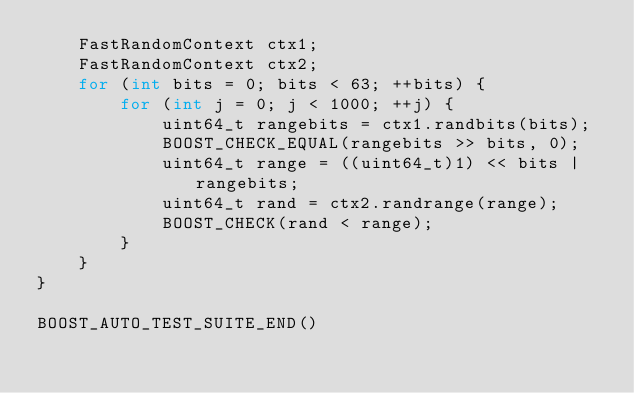<code> <loc_0><loc_0><loc_500><loc_500><_C++_>    FastRandomContext ctx1;
    FastRandomContext ctx2;
    for (int bits = 0; bits < 63; ++bits) {
        for (int j = 0; j < 1000; ++j) {
            uint64_t rangebits = ctx1.randbits(bits);
            BOOST_CHECK_EQUAL(rangebits >> bits, 0);
            uint64_t range = ((uint64_t)1) << bits | rangebits;
            uint64_t rand = ctx2.randrange(range);
            BOOST_CHECK(rand < range);
        }
    }
}

BOOST_AUTO_TEST_SUITE_END()
</code> 